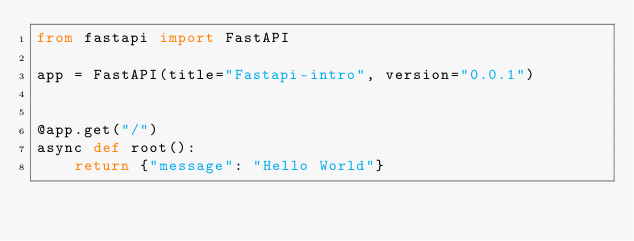Convert code to text. <code><loc_0><loc_0><loc_500><loc_500><_Python_>from fastapi import FastAPI

app = FastAPI(title="Fastapi-intro", version="0.0.1")


@app.get("/")
async def root():
    return {"message": "Hello World"}
</code> 